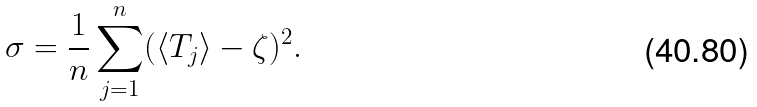<formula> <loc_0><loc_0><loc_500><loc_500>\sigma = \frac { 1 } { n } \sum _ { j = 1 } ^ { n } ( \langle T _ { j } \rangle - \zeta ) ^ { 2 } .</formula> 